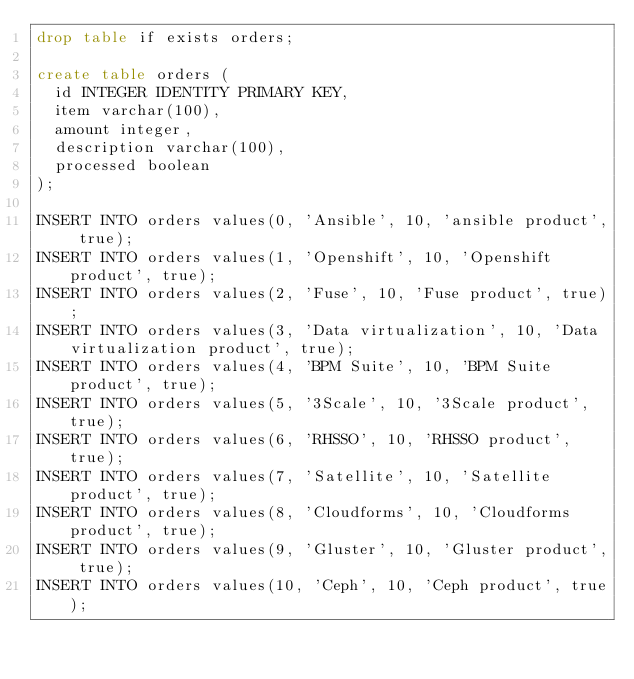Convert code to text. <code><loc_0><loc_0><loc_500><loc_500><_SQL_>drop table if exists orders;

create table orders (
  id INTEGER IDENTITY PRIMARY KEY,
  item varchar(100),
  amount integer,
  description varchar(100),
  processed boolean
);

INSERT INTO orders values(0, 'Ansible', 10, 'ansible product', true);
INSERT INTO orders values(1, 'Openshift', 10, 'Openshift product', true);
INSERT INTO orders values(2, 'Fuse', 10, 'Fuse product', true);
INSERT INTO orders values(3, 'Data virtualization', 10, 'Data virtualization product', true);
INSERT INTO orders values(4, 'BPM Suite', 10, 'BPM Suite product', true);
INSERT INTO orders values(5, '3Scale', 10, '3Scale product', true);
INSERT INTO orders values(6, 'RHSSO', 10, 'RHSSO product', true);
INSERT INTO orders values(7, 'Satellite', 10, 'Satellite product', true);
INSERT INTO orders values(8, 'Cloudforms', 10, 'Cloudforms product', true);
INSERT INTO orders values(9, 'Gluster', 10, 'Gluster product', true);
INSERT INTO orders values(10, 'Ceph', 10, 'Ceph product', true);</code> 